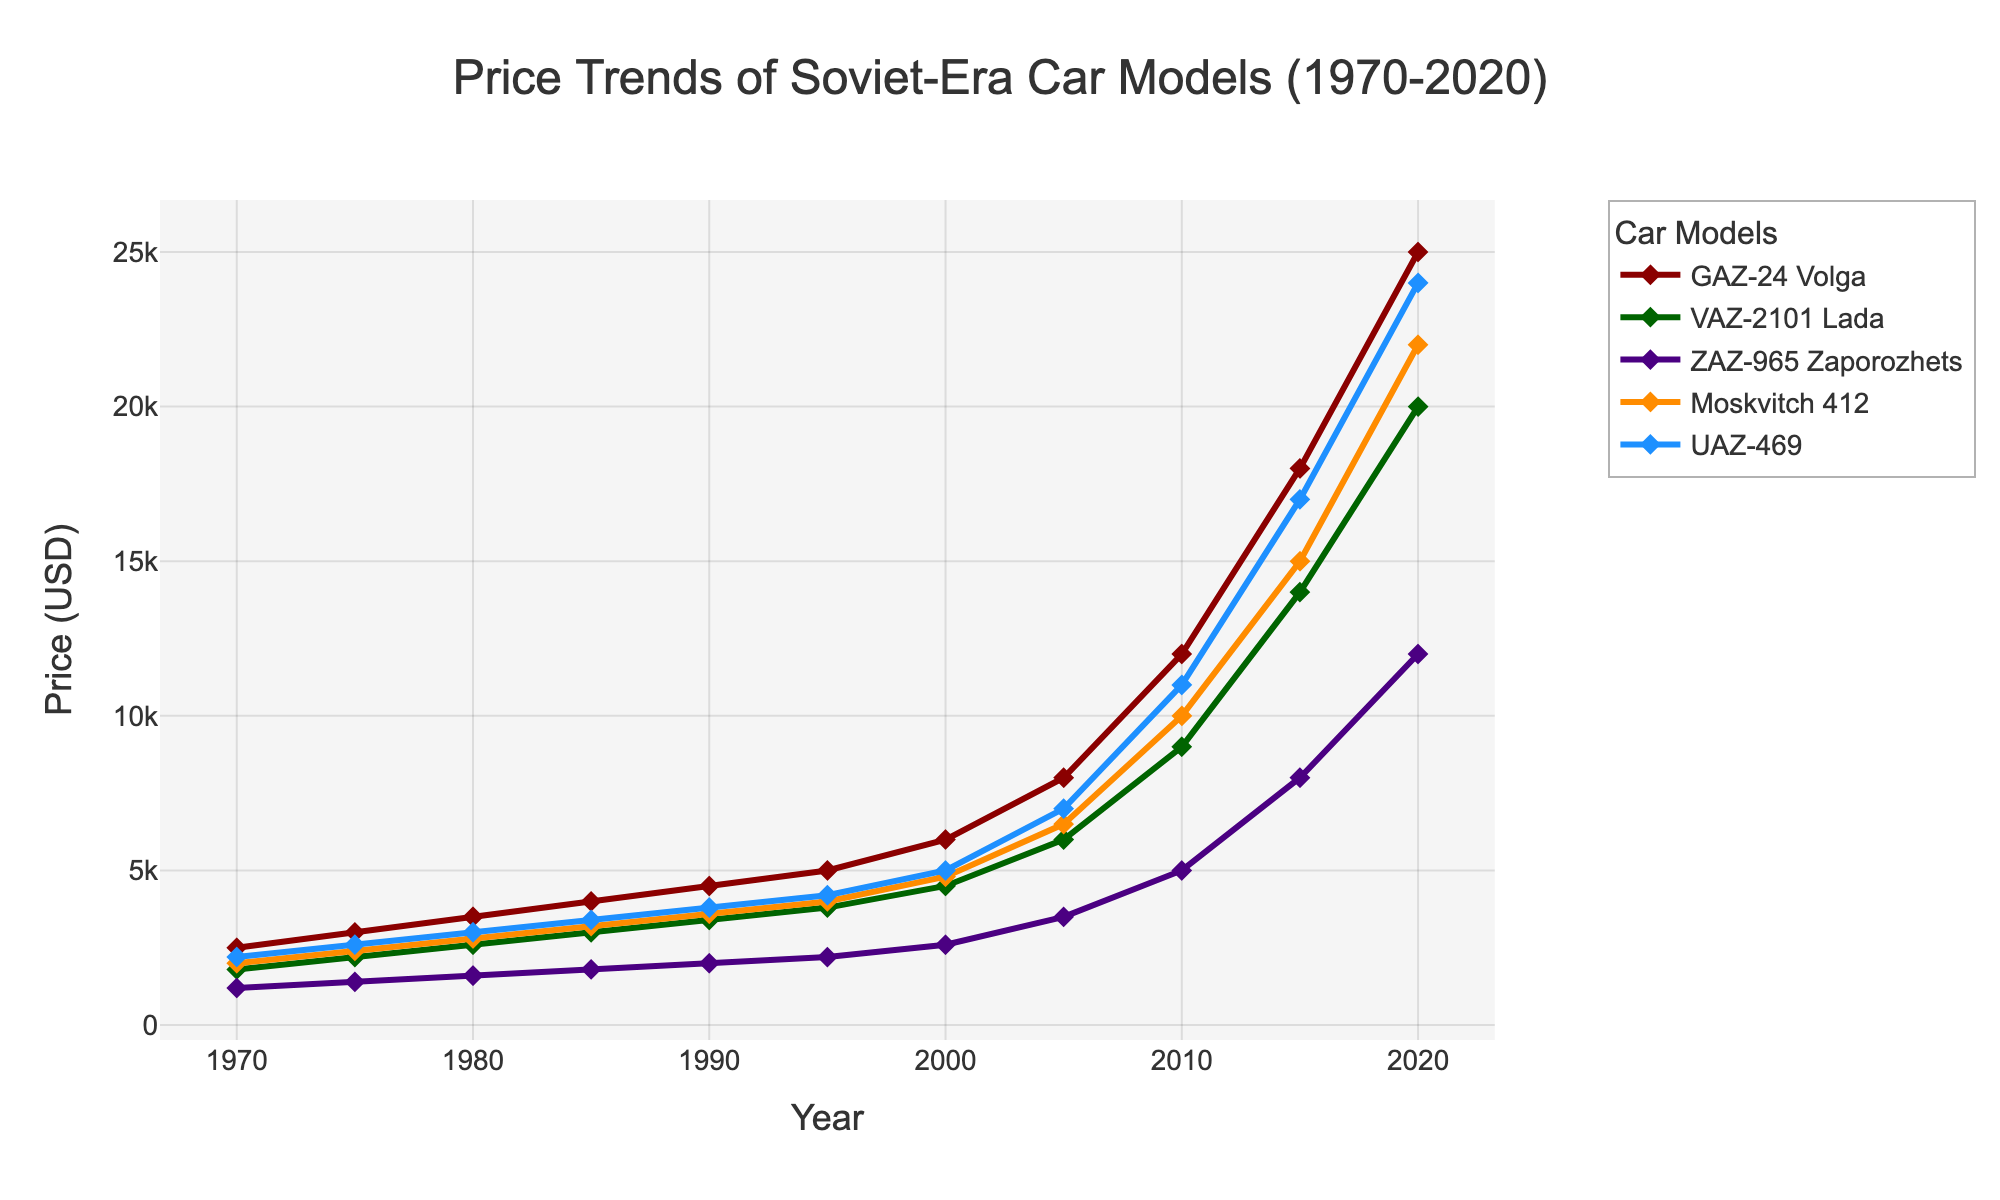Which car model had the highest price in 2020? By looking at the plotted points for each car model in 2020, the GAZ-24 Volga reaches the highest value.
Answer: GAZ-24 Volga By how much did the price of the VAZ-2101 Lada increase from 1980 to 2000? To determine this, identify the price of the VAZ-2101 Lada in both years: 2600 in 1980 and 4500 in 2000. The difference is 4500 - 2600 = 1900.
Answer: 1900 Which year had the steepest increase in price for the Moskvitch 412? Examine the slopes of the line segments for the Moskvitch 412. The steepest increase occurs between 2005 and 2010, indicating the largest rise in a short period.
Answer: 2005-2010 Did any car model’s price decrease at any point between 1970 to 2020? By visually inspecting the lines, none of the car models show a downward trend within the specified timeframe. All models’ prices consistently increased.
Answer: No How does the price trend of the ZAZ-965 Zaporozhets compare to that of the UAZ-469 from 1985 to 1990? Identify the prices for both models in 1985 and 1990: ZAZ-965 Zaporozhets (1800 to 2000) and UAZ-469 (3400 to 3800). Both show an equal price increase of 200 during this period.
Answer: Equal increase What is the average increase in price per decade for the GAZ-24 Volga from 1970 to 2020? Calculate the total increase and divide by the number of decades: Increase is 25000 (2020) - 2500 (1970) = 22500. Number of decades is (2020-1970)/10 = 5. Average = 22500/5 = 4500.
Answer: 4500 Which car model had the smallest price increase between 1970 and 1975? Compare the increase in prices for all models between 1970 and 1975: GAZ-24 Volga (500), VAZ-2101 Lada (400), ZAZ-965 Zaporozhets (200), Moskvitch 412 (400), UAZ-469 (400). ZAZ-965 Zaporozhets has the smallest increase.
Answer: ZAZ-965 Zaporozhets Which car model has the least fluctuation in price over the 50 years? Examine the smoothness and consistency of the lines for each model; the UAZ-469 has a more consistent trend compared to others.
Answer: UAZ-469 